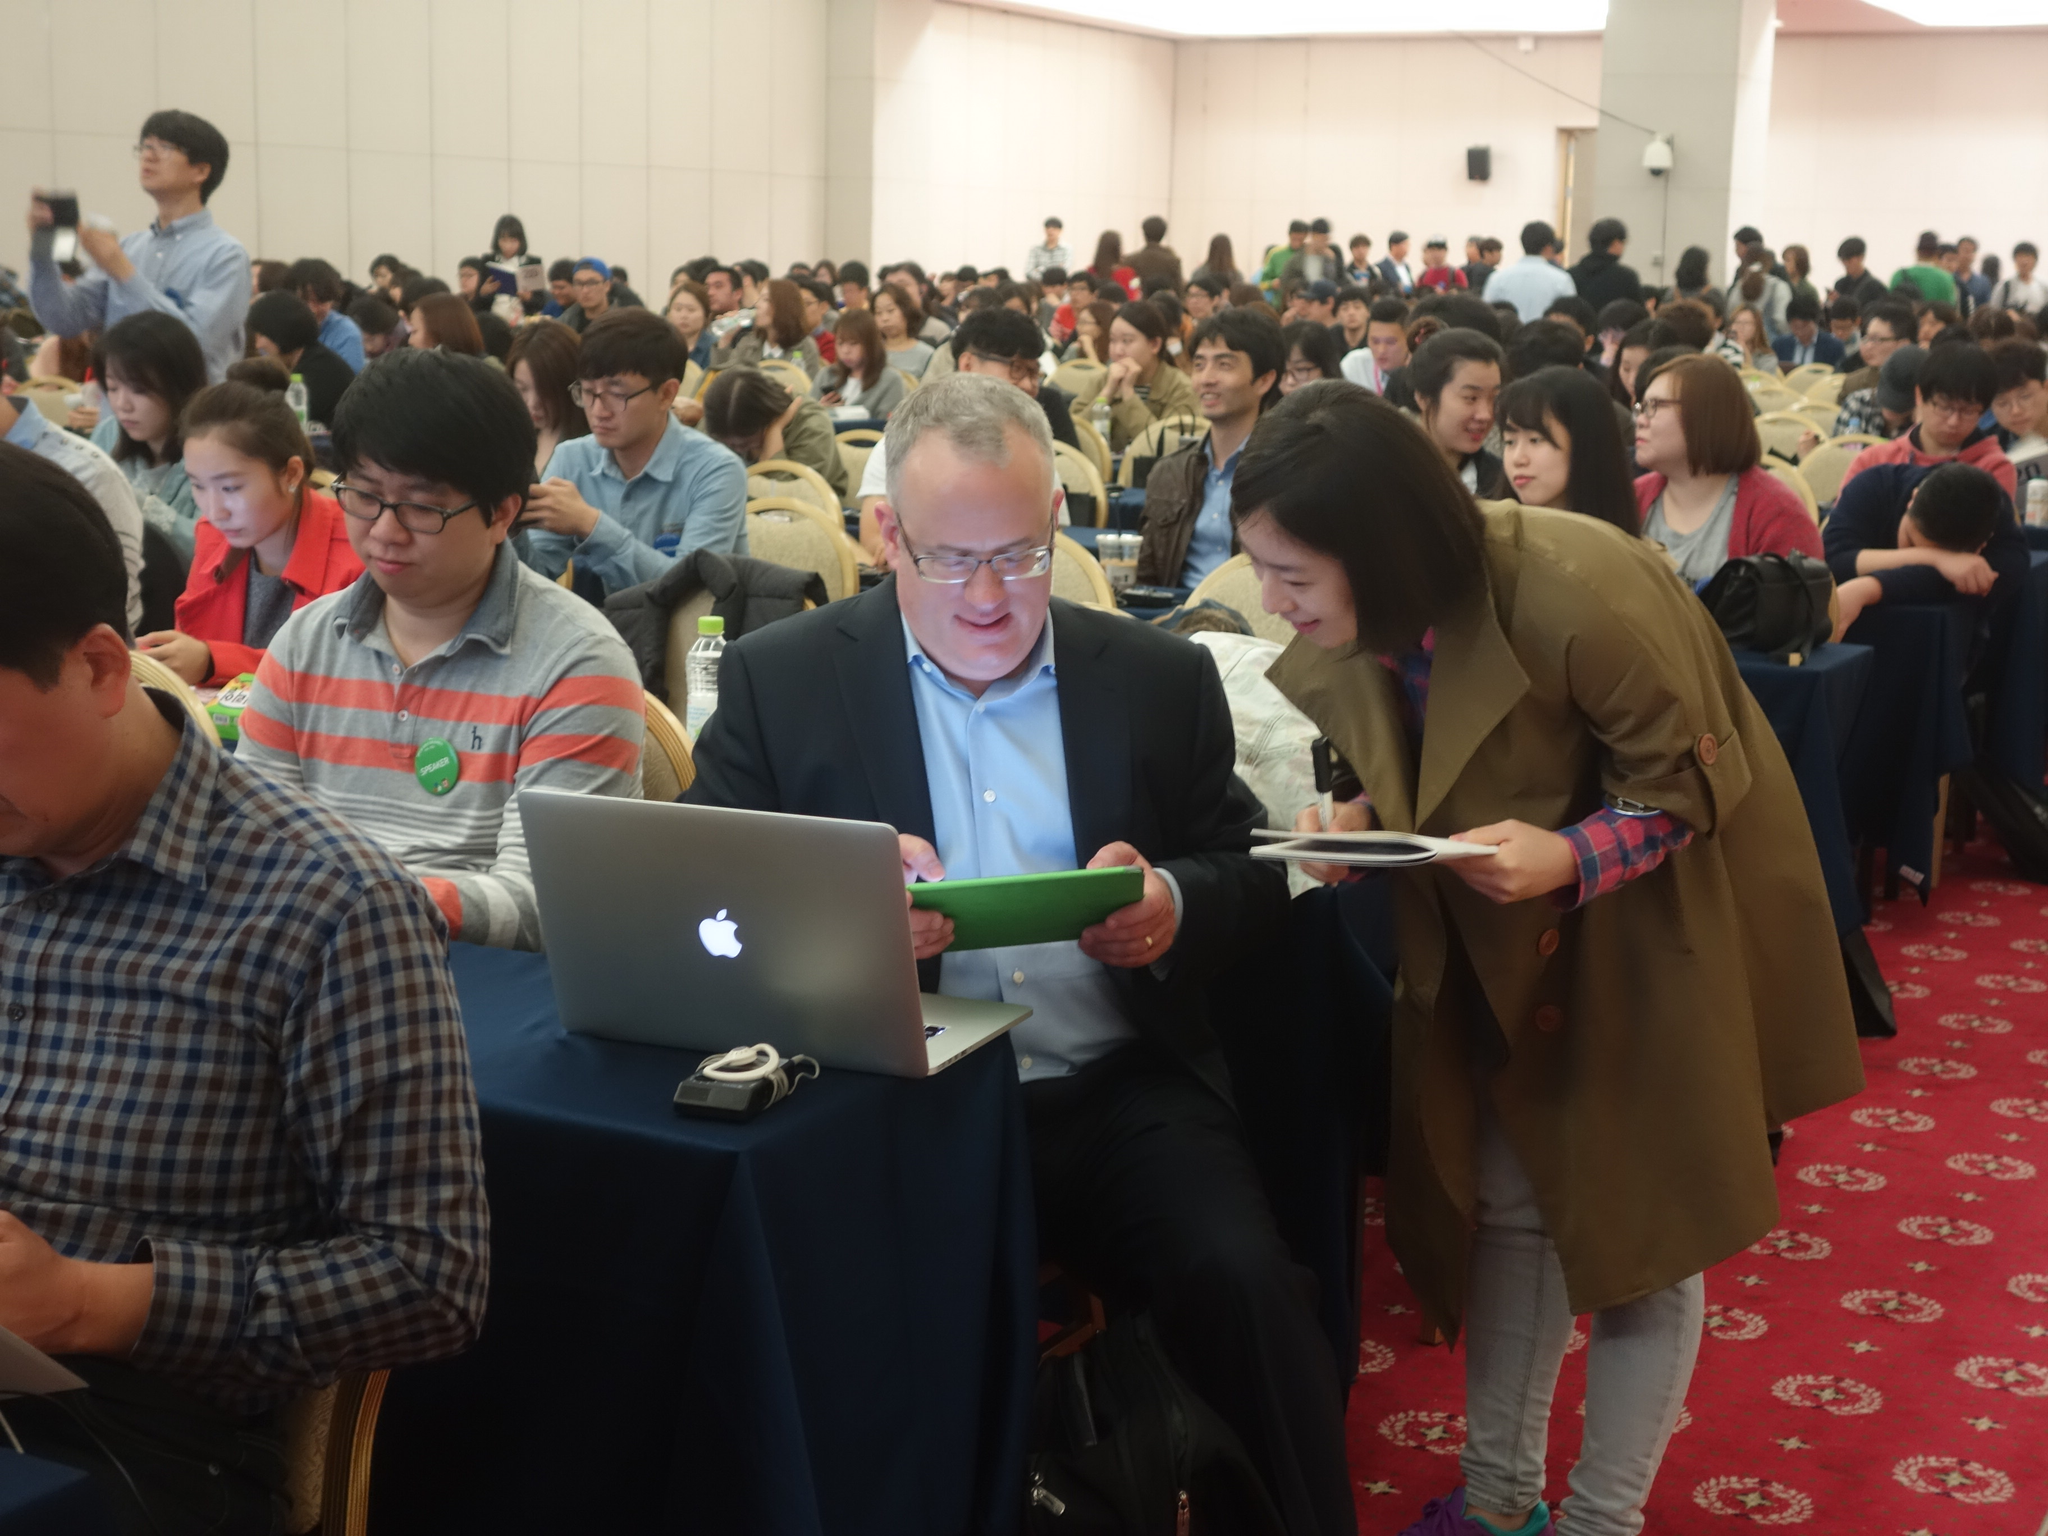In one or two sentences, can you explain what this image depicts? This is an inside view. Here I can see a crowd of people sitting on the chairs and there are few tables which are covered with the clothes. In the middle of the image there is a man holding a device in the hands and looking into the device. Beside him there is a woman standing and holding a book in the hands. On the left side there is a man standing. In the background there is a wall. At the bottom there is a mat. 